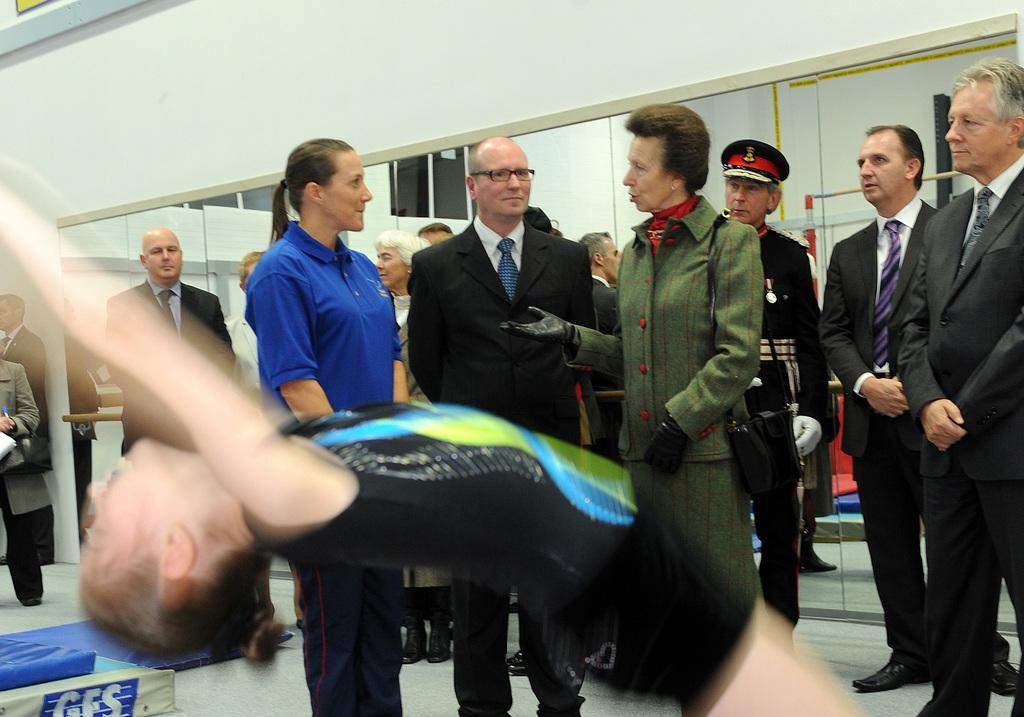Who is the main subject in the image? There is a woman at the bottom of the image. What is the woman doing in the image? The woman is doing something, but we cannot determine the specific action from the provided facts. Can you describe the people in the middle of the image? There are people standing in the middle of the image. What is visible in the background of the image? There is a wall in the background of the image. What type of pickle is the woman holding in the image? There is no pickle present in the image. Can you tell me how many hens are visible in the image? There are no hens present in the image. 